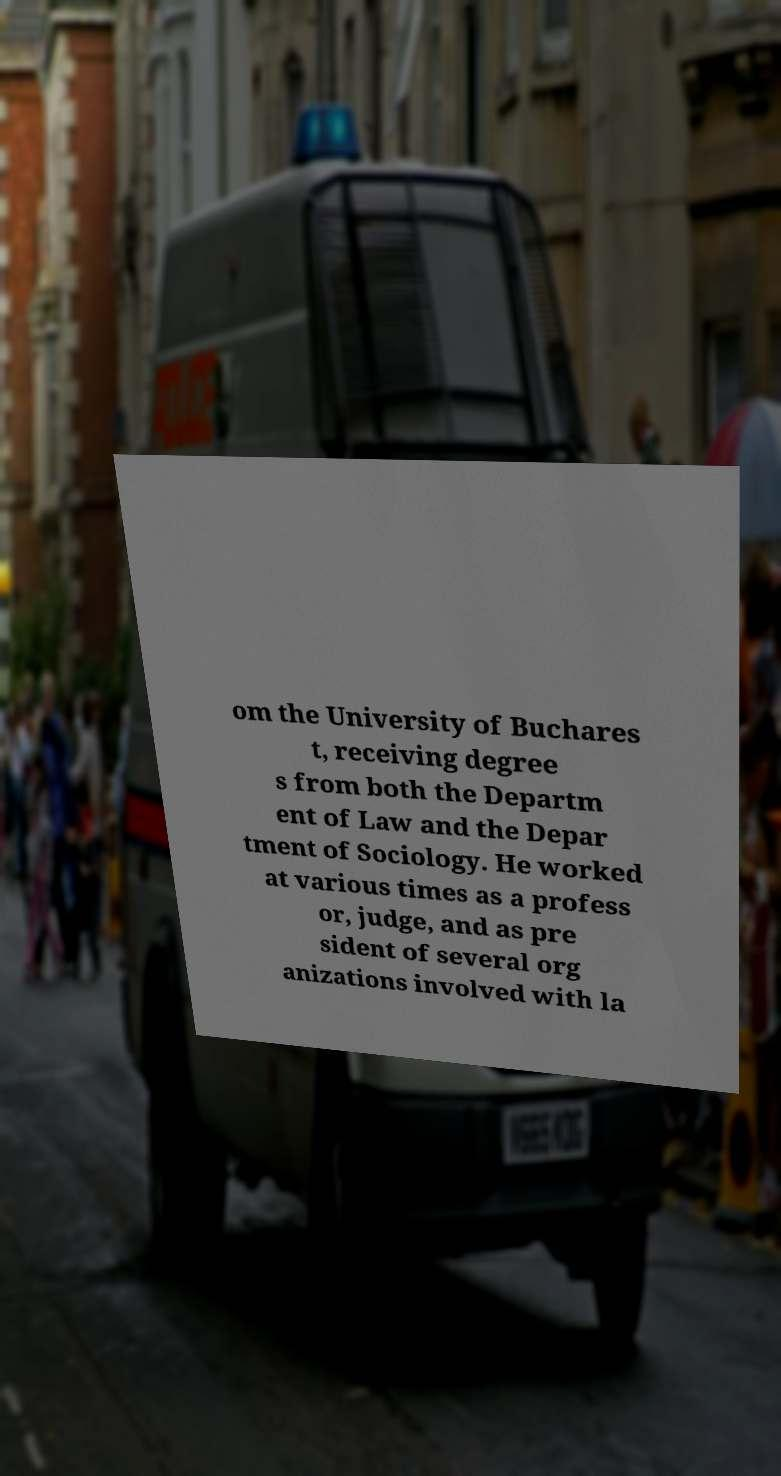Please identify and transcribe the text found in this image. om the University of Buchares t, receiving degree s from both the Departm ent of Law and the Depar tment of Sociology. He worked at various times as a profess or, judge, and as pre sident of several org anizations involved with la 